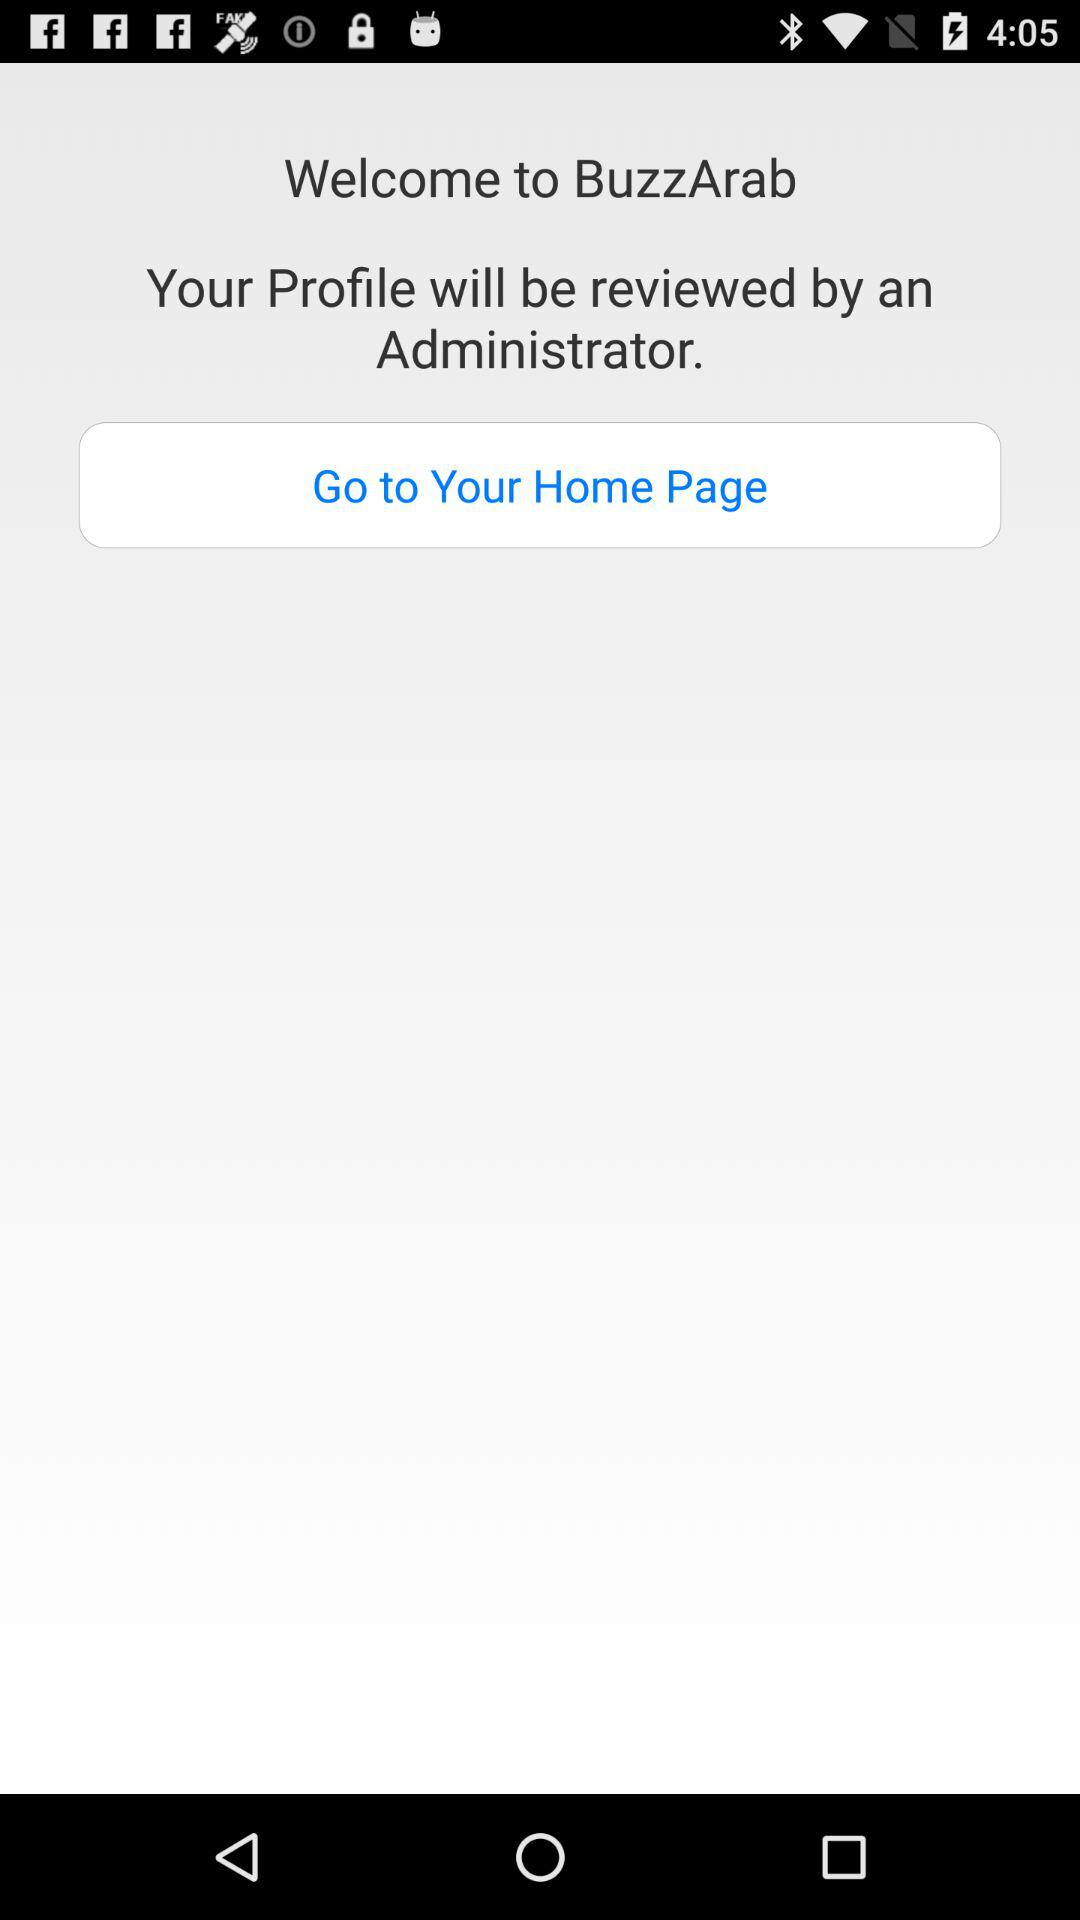What is the name of the application? The name of the application is "BuzzArab". 